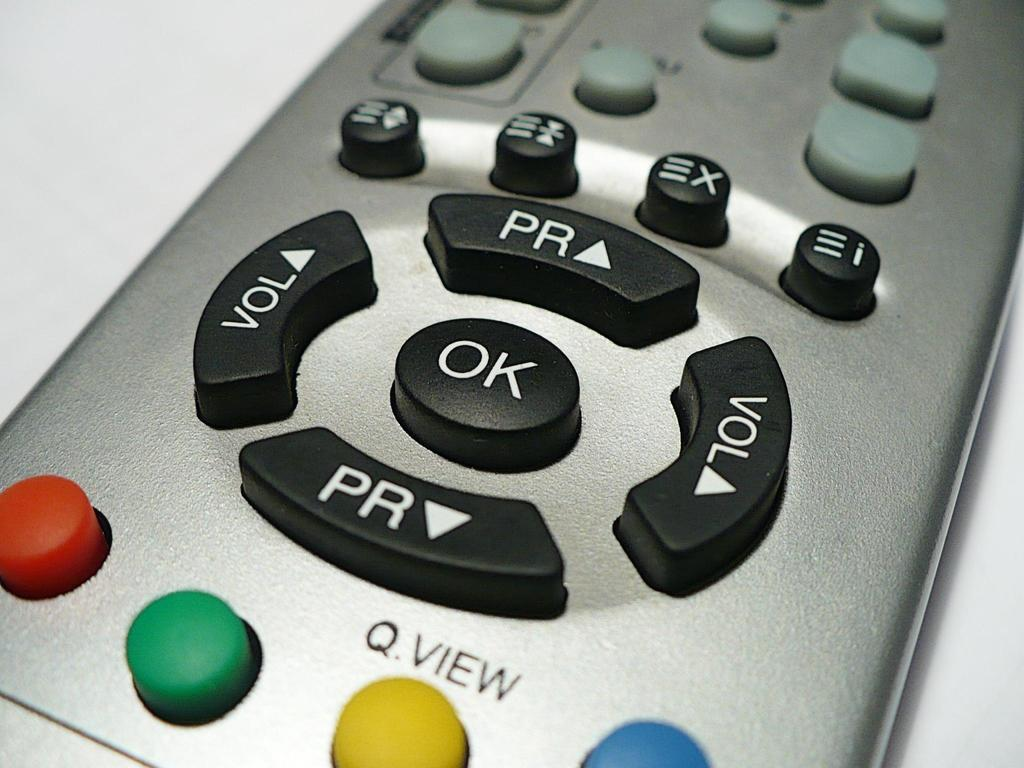Provide a one-sentence caption for the provided image. Silver remote that works for a television or cable. 